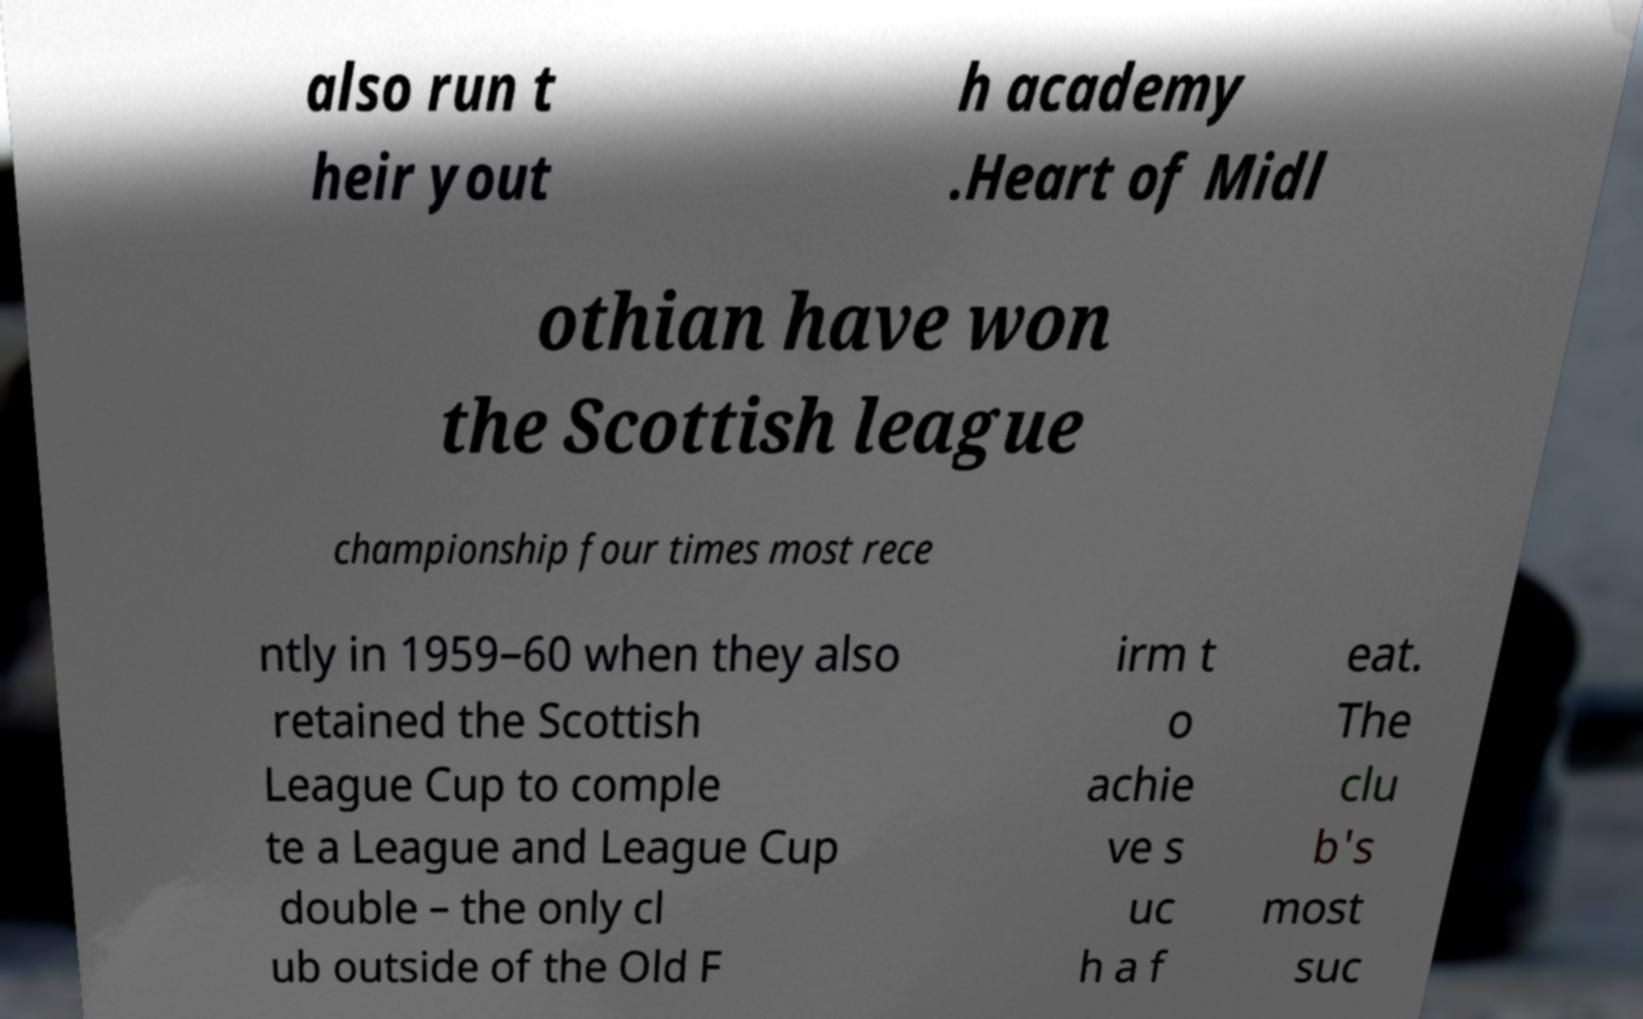Could you assist in decoding the text presented in this image and type it out clearly? also run t heir yout h academy .Heart of Midl othian have won the Scottish league championship four times most rece ntly in 1959–60 when they also retained the Scottish League Cup to comple te a League and League Cup double – the only cl ub outside of the Old F irm t o achie ve s uc h a f eat. The clu b's most suc 